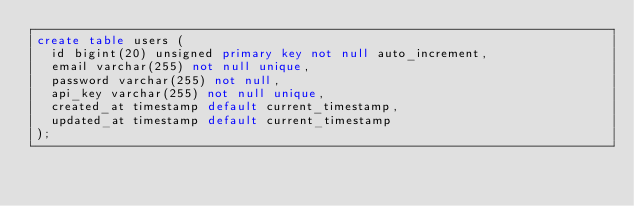Convert code to text. <code><loc_0><loc_0><loc_500><loc_500><_SQL_>create table users (
  id bigint(20) unsigned primary key not null auto_increment,
  email varchar(255) not null unique,
  password varchar(255) not null,
  api_key varchar(255) not null unique,
  created_at timestamp default current_timestamp,
  updated_at timestamp default current_timestamp
);</code> 